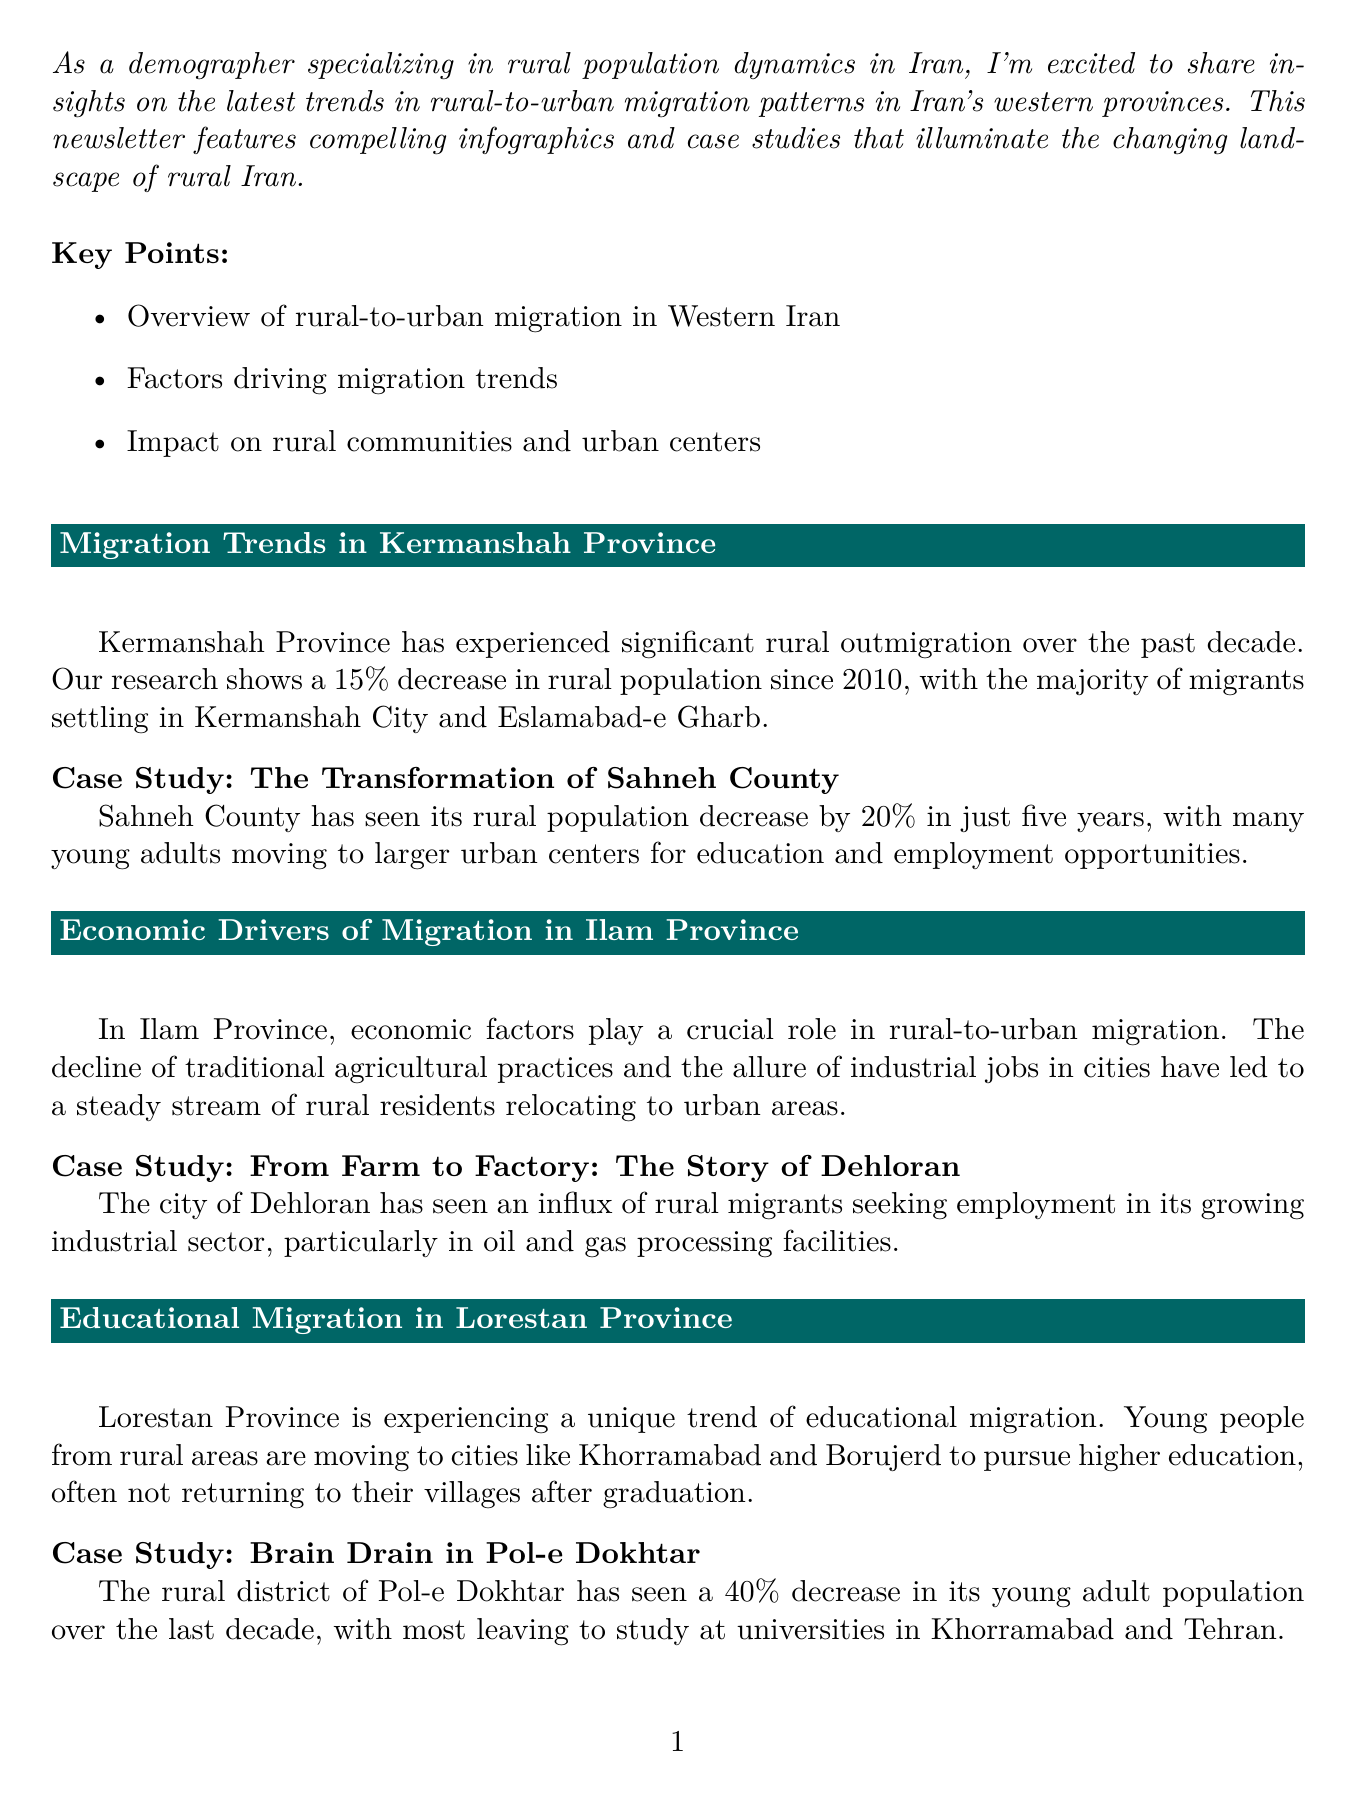What is the total population decrease in Kermanshah Province since 2010? The population decline is calculated as the difference between the rural populations in 2010 and 2020, which is 600,000 - 510,000.
Answer: 90,000 What percentage of rural migrants in Ilam work in the services sector? The percentage for the services sector is provided in the infographic detailing employment sectors of rural-urban migrants, which states it as 45%.
Answer: 45% What is the population decrease percentage in Sahneh County over five years? The document states that Sahneh County has seen a decrease of 20% in its rural population over five years.
Answer: 20% Which city do many migrants from Pol-e Dokhtar move to for higher education? The document lists Khorramabad as a primary destination for young adults from Pol-e Dokhtar pursuing higher education.
Answer: Khorramabad What trend is prevalent among young migrants in Lorestan Province? The document specifies that the trend is primarily educational migration, with young individuals moving to urban centers for education.
Answer: Educational migration How much did the rural population decrease in Lorestan over the last decade? The document does not provide an exact figure for the total decrease in Lorestan's rural population, so this would require inferential reasoning or additional data not contained in the document.
Answer: Not specified What title is given to the case study about Dehloran in Ilam Province? The title for the case study on Dehloran discusses the migration to industrial jobs, which is "From Farm to Factory: The Story of Dehloran."
Answer: From Farm to Factory: The Story of Dehloran What major factor drives migration trends in Ilam Province? The document highlights economic factors as a significant driver, particularly the decline of traditional agricultural practices.
Answer: Economic factors What is the main theme of the newsletter? The overall theme focuses on trends in rural-to-urban migration patterns in Western Iran.
Answer: Trends in rural-to-urban migration patterns in Western Iran 